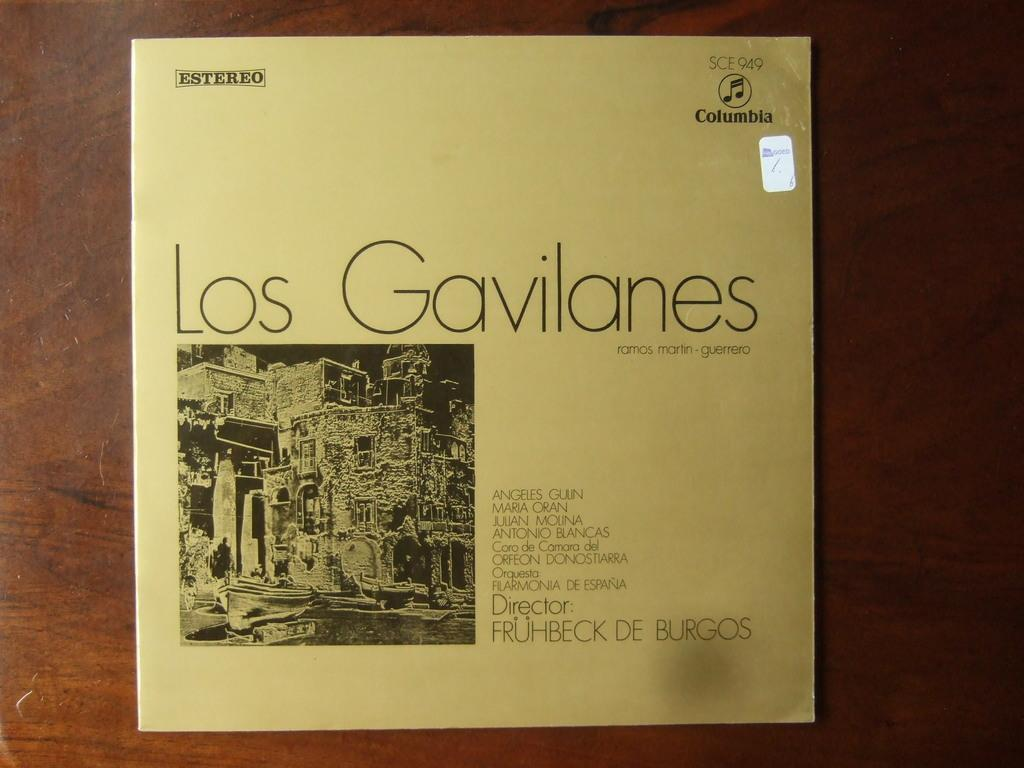<image>
Create a compact narrative representing the image presented. A record of Los Gavilates from Columbia Records 